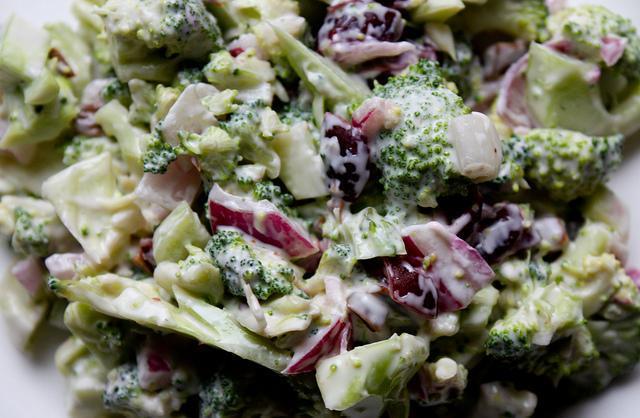How many broccolis can be seen?
Give a very brief answer. 11. 